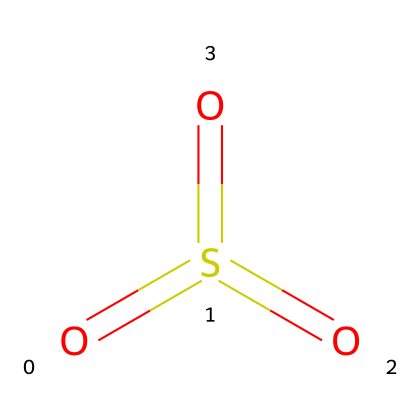What is the name of the chemical represented by this structure? The structure corresponds to sulfuric acid anhydride, commonly recognized by its chemical formula and arrangement of atoms. The presence of sulfur connected to three oxygen atoms indicates it is a derivative of sulfuric acid.
Answer: sulfuric acid anhydride How many sulfur atoms are in the structure? There is one sulfur atom in the structure, which is identified by the single 'S' in the SMILES representation.
Answer: one How many oxygen atoms are present in this compound? The structure contains four oxygen atoms as indicated by four 'O' characters in the SMILES string, one of which is bonded to the sulfur atom.
Answer: four What type of bonding is present between the sulfur and oxygen? The bonding between sulfur and oxygen consists of double bonds, as indicated by the '=' signs in the SMILES notation. Each 'O' is connected to 'S' by a double bond, which is crucial to its properties as an anhydride.
Answer: double bonds What property does sulfuric acid anhydride exhibit when it comes into contact with water? Sulfuric acid anhydride reacts vigorously with water to form sulfuric acid, demonstrating its highly reactive nature as an anhydride. This reflects its chemical behavior of forming acids upon hydration.
Answer: forms sulfuric acid Is this compound an acidic or a basic anhydride? This compound is classified as an acidic anhydride because it reacts with water to produce an acid (sulfuric acid), highlighting its acidic characteristics.
Answer: acidic anhydride 